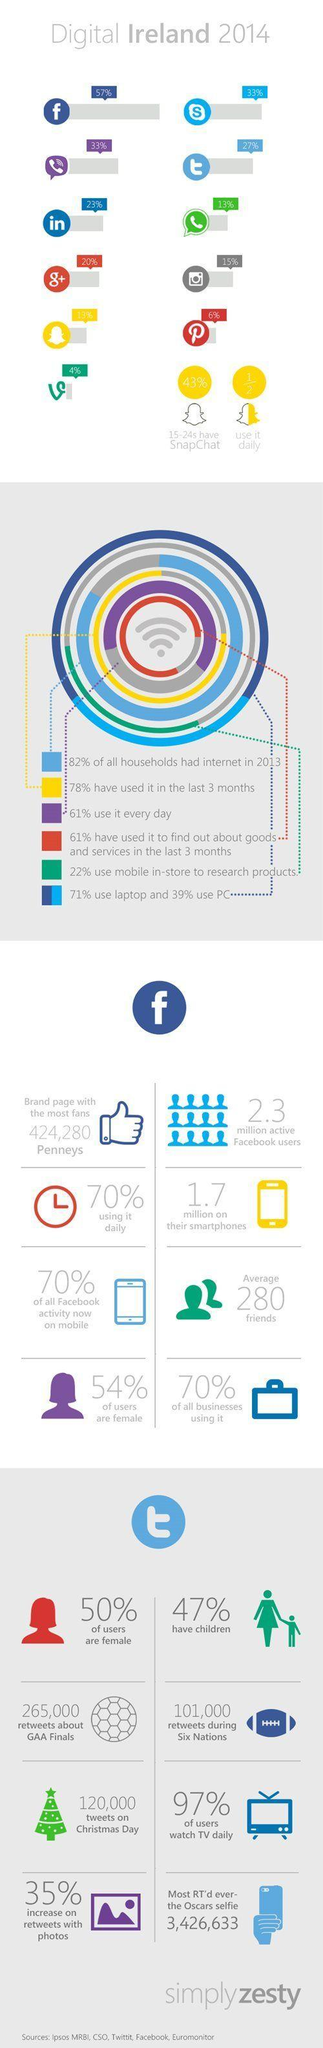What percent of the Twitter users in Ireland are female in 2014?
Answer the question with a short phrase. 50% What percent of the Irish people use facebook daily in 2014? 70% What is the percentage of Viber users in Ireland in 2014? 33% What is the percentage of Skype users in Ireland in 2014? 33% What percentage of the Irish people use facebook in laptops in 2014? 71% What percentage of the twitter users in Ireland do not watch TV daily? 3% What is the percentage of Linkedin users in Ireland in 2014? 23% What percentage of the Irish people use Viber everyday in 2014? 61% What is the percentage of WhatsApp users in Ireland in 2014? 13% What percent of the facebook users in Ireland are males in 2014? 46% 